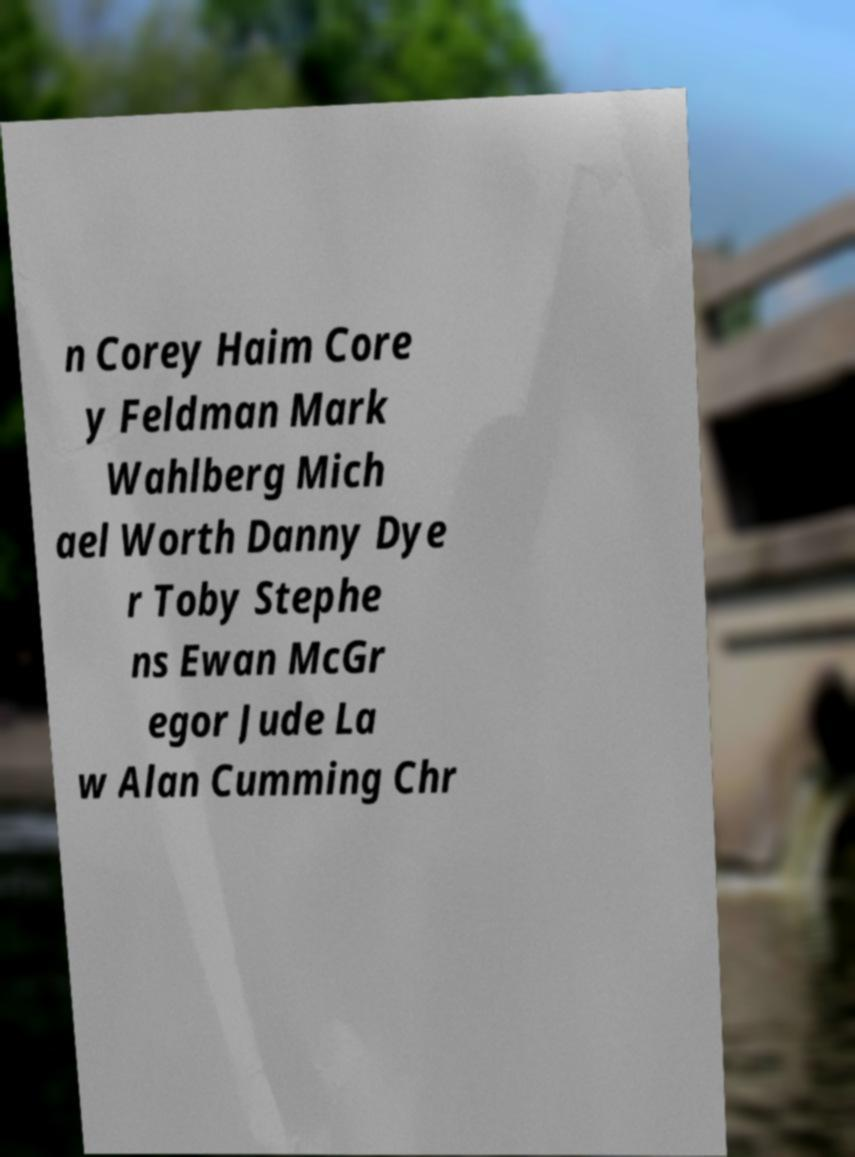Can you read and provide the text displayed in the image?This photo seems to have some interesting text. Can you extract and type it out for me? n Corey Haim Core y Feldman Mark Wahlberg Mich ael Worth Danny Dye r Toby Stephe ns Ewan McGr egor Jude La w Alan Cumming Chr 